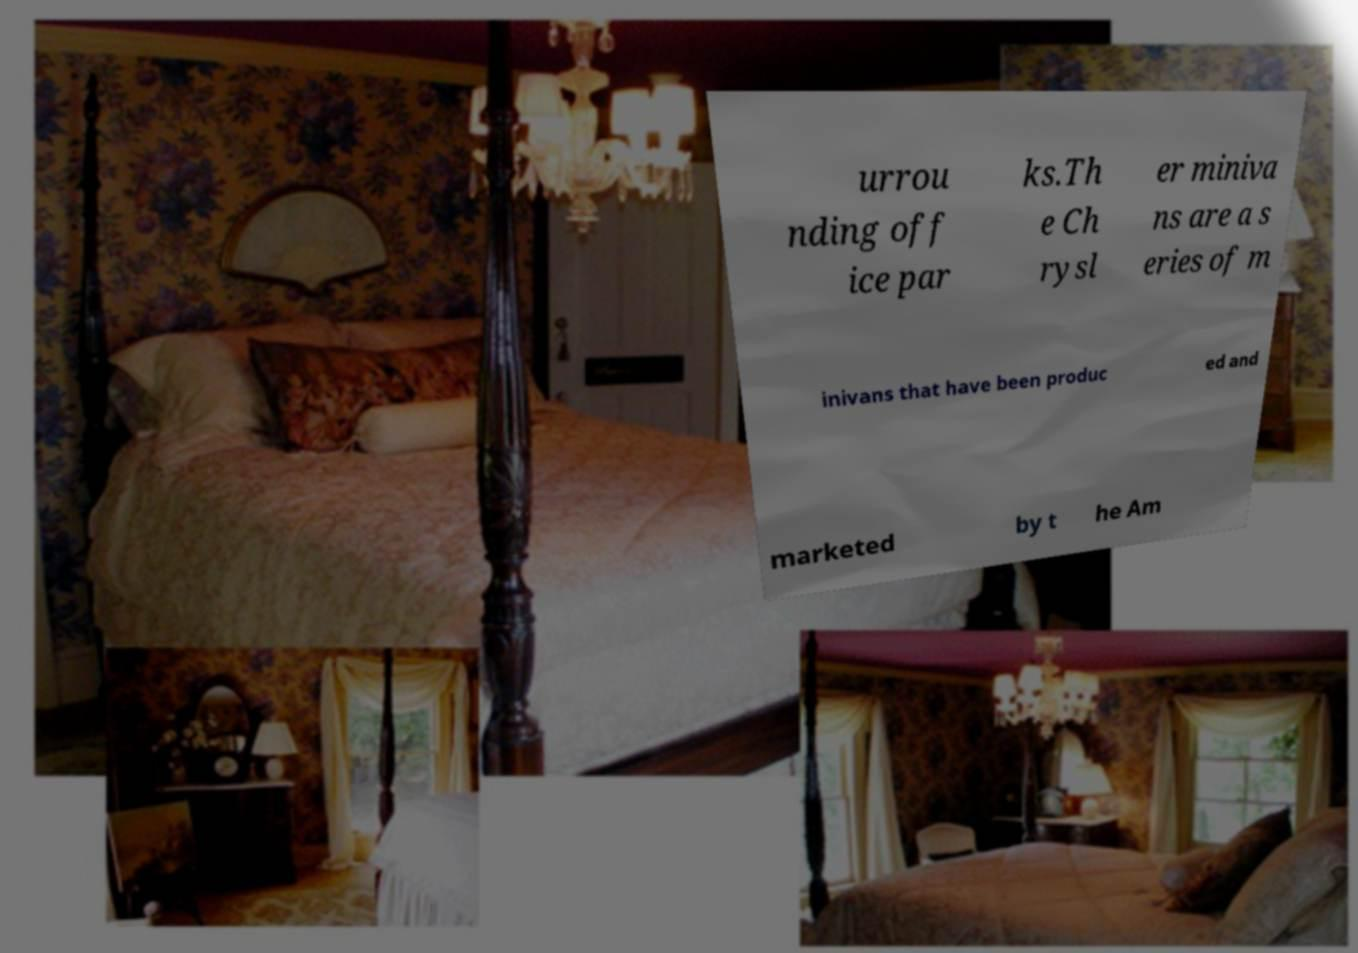Please read and relay the text visible in this image. What does it say? urrou nding off ice par ks.Th e Ch rysl er miniva ns are a s eries of m inivans that have been produc ed and marketed by t he Am 